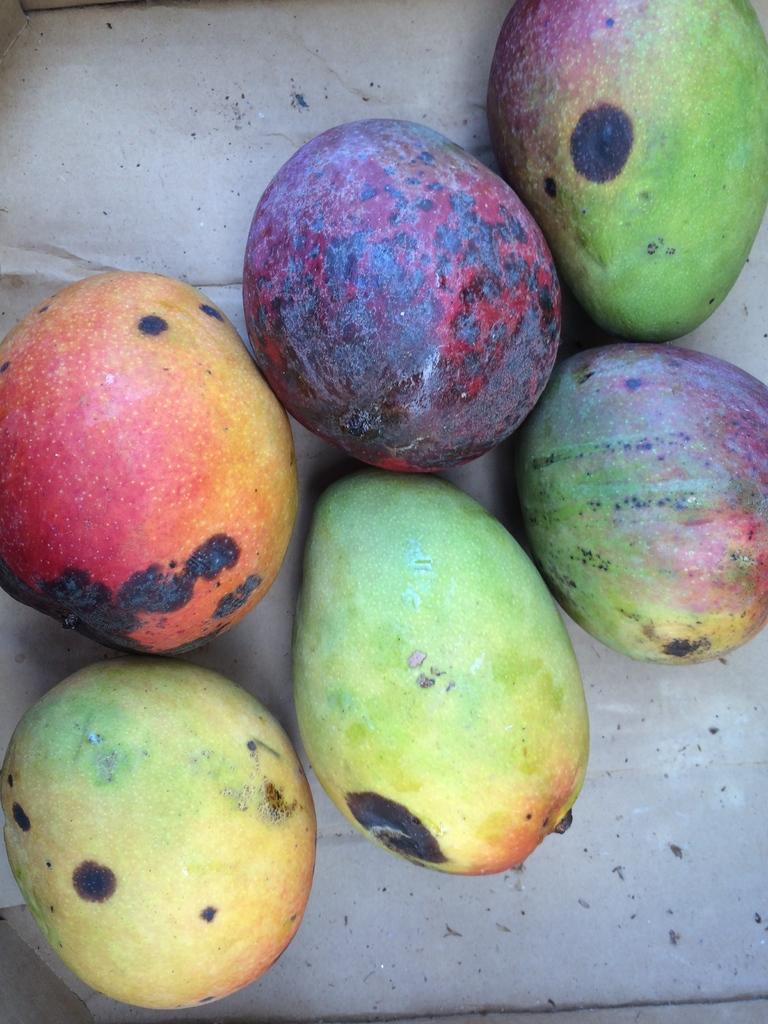What types of fruits are present in the image? There are different types of mangoes in the image. How are the mangoes arranged in the image? The mangoes are placed on a surface in the image. What type of crate is visible in the image? There is no crate present in the image; it only features different types of mangoes placed on a surface. 